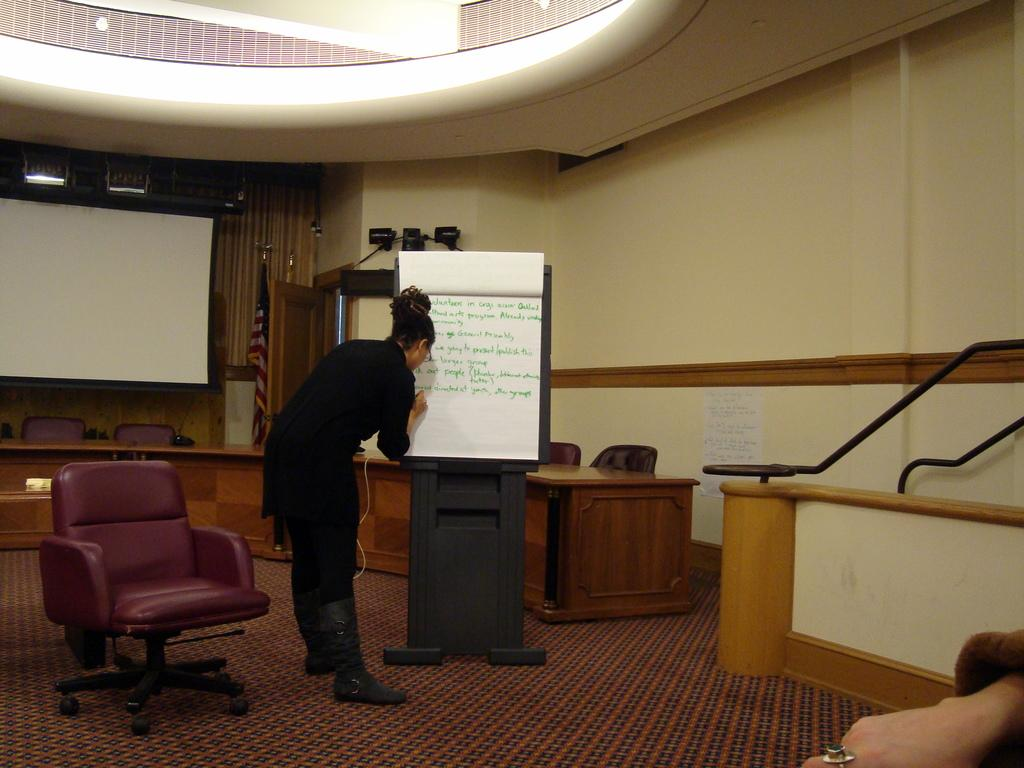Who is present in the image? There is a woman in the image. What is the woman wearing? The woman is wearing a black dress. What is the woman doing in the image? The woman is writing on a paper. How is the paper positioned in the image? The paper is attached to a black stand. What is located beside the woman? There is a chair beside the woman. What can be seen in the background of the image? There is a projector in the background of the image. Can you see any toys in the image? There are no toys present in the image. What type of cave is visible in the background of the image? There is no cave present in the image; it features a projector in the background. 